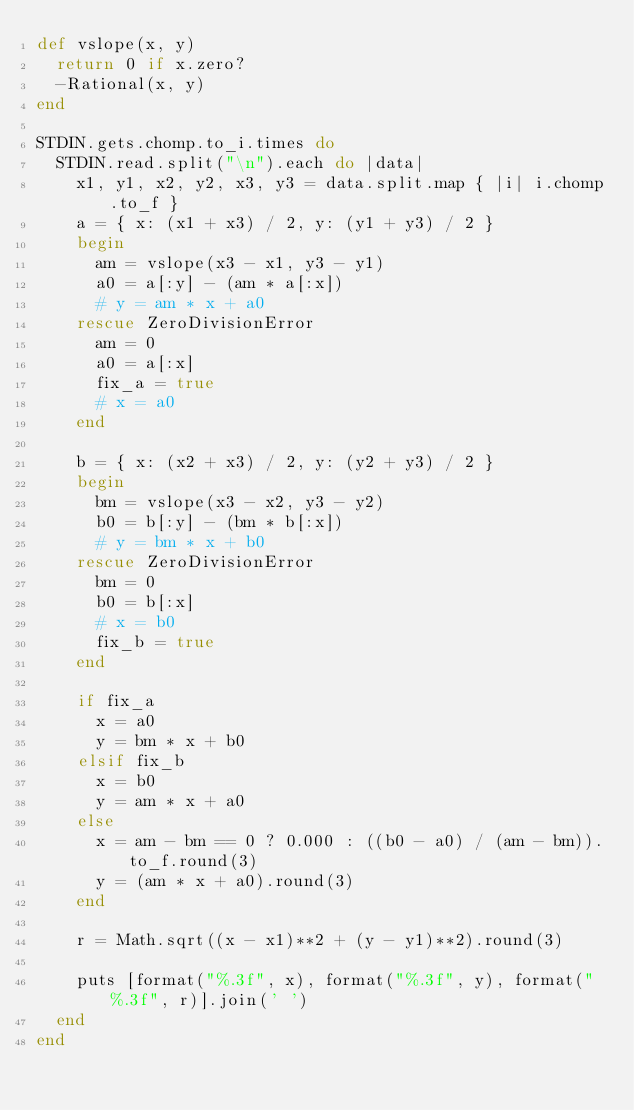<code> <loc_0><loc_0><loc_500><loc_500><_Ruby_>def vslope(x, y)
  return 0 if x.zero?
  -Rational(x, y)
end

STDIN.gets.chomp.to_i.times do
  STDIN.read.split("\n").each do |data|
    x1, y1, x2, y2, x3, y3 = data.split.map { |i| i.chomp.to_f }
    a = { x: (x1 + x3) / 2, y: (y1 + y3) / 2 }
    begin
      am = vslope(x3 - x1, y3 - y1)
      a0 = a[:y] - (am * a[:x])
      # y = am * x + a0
    rescue ZeroDivisionError
      am = 0
      a0 = a[:x]
      fix_a = true
      # x = a0
    end

    b = { x: (x2 + x3) / 2, y: (y2 + y3) / 2 }
    begin
      bm = vslope(x3 - x2, y3 - y2)
      b0 = b[:y] - (bm * b[:x])
      # y = bm * x + b0
    rescue ZeroDivisionError
      bm = 0
      b0 = b[:x]
      # x = b0
      fix_b = true
    end

    if fix_a
      x = a0
      y = bm * x + b0
    elsif fix_b
      x = b0
      y = am * x + a0
    else
      x = am - bm == 0 ? 0.000 : ((b0 - a0) / (am - bm)).to_f.round(3)
      y = (am * x + a0).round(3)
    end

    r = Math.sqrt((x - x1)**2 + (y - y1)**2).round(3)

    puts [format("%.3f", x), format("%.3f", y), format("%.3f", r)].join(' ')
  end
end</code> 